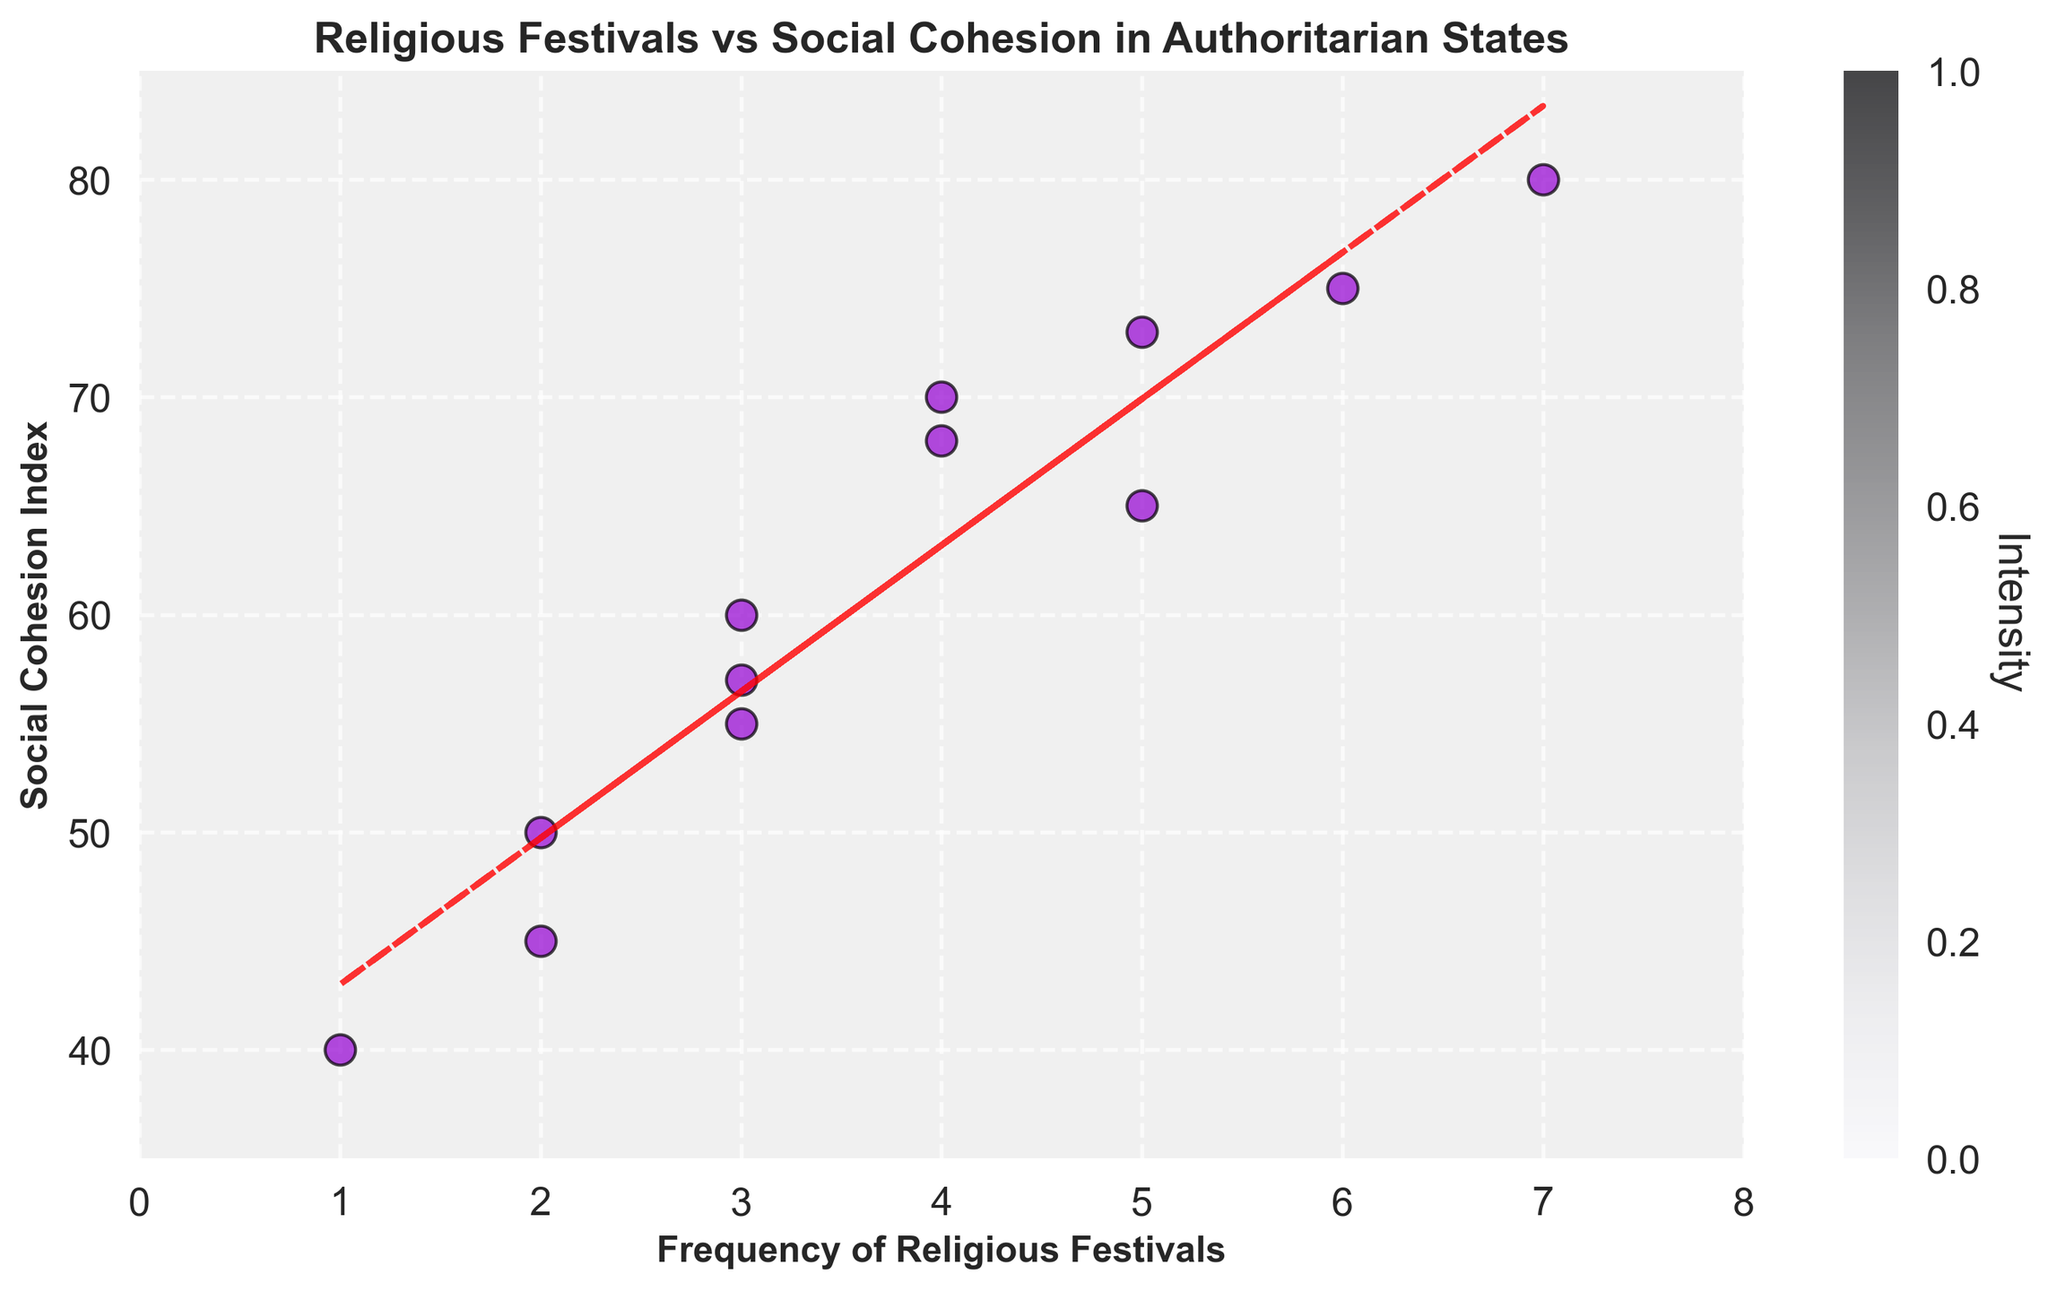What's the title of the scatter plot? The title of the plot is typically located at the top center of the figure.
Answer: Religious Festivals vs Social Cohesion in Authoritarian States How many data points are there in the scatter plot? By counting the number of individual points or markers in the plot, we determine the total number of data points.
Answer: 12 What are the labels of the x-axis and y-axis? The labels for the axes are found adjacent to the respective axes of the plot.
Answer: Frequency of Religious Festivals (x-axis) and Social Cohesion Index (y-axis) What is the range of the Social Cohesion Index? The range is determined by identifying the minimum and maximum values along the y-axis and extending slightly beyond the plotted points.
Answer: 40 to 80 What can you infer from the trend line in the plot? The trend line shows the general direction that the data points are moving, which suggests whether the relationship between the variables is positive, negative, or neutral.
Answer: There is a positive correlation between the frequency of religious festivals and the social cohesion index How does the Social Cohesion Index vary with the frequency of religious festivals? By analyzing the slope of the trend line, we understand whether the Social Cohesion Index increases, decreases, or stays the same as the frequency of religious festivals changes.
Answer: It increases with the frequency of religious festivals Which data point has the highest value for the Social Cohesion Index? What is its corresponding frequency of religious festivals? By locating the highest point on the y-axis and noting its corresponding x-axis value, we determine the specific data point.
Answer: The highest value is 80, with a frequency of 7 Are there any outliers in the scatter plot? An outlier can be identified as a point that significantly deviates from the overall pattern of the data indicated by the trend line.
Answer: No noticeable outliers What is the general color used for the data points in the scatter plot? The color of the data points can be determined by observing the plot.
Answer: Dark violet What does the color bar on the right side of the plot represent? The color bar serves as a legend to indicate the value represented by different intensities or colors of the data points.
Answer: Intensity 